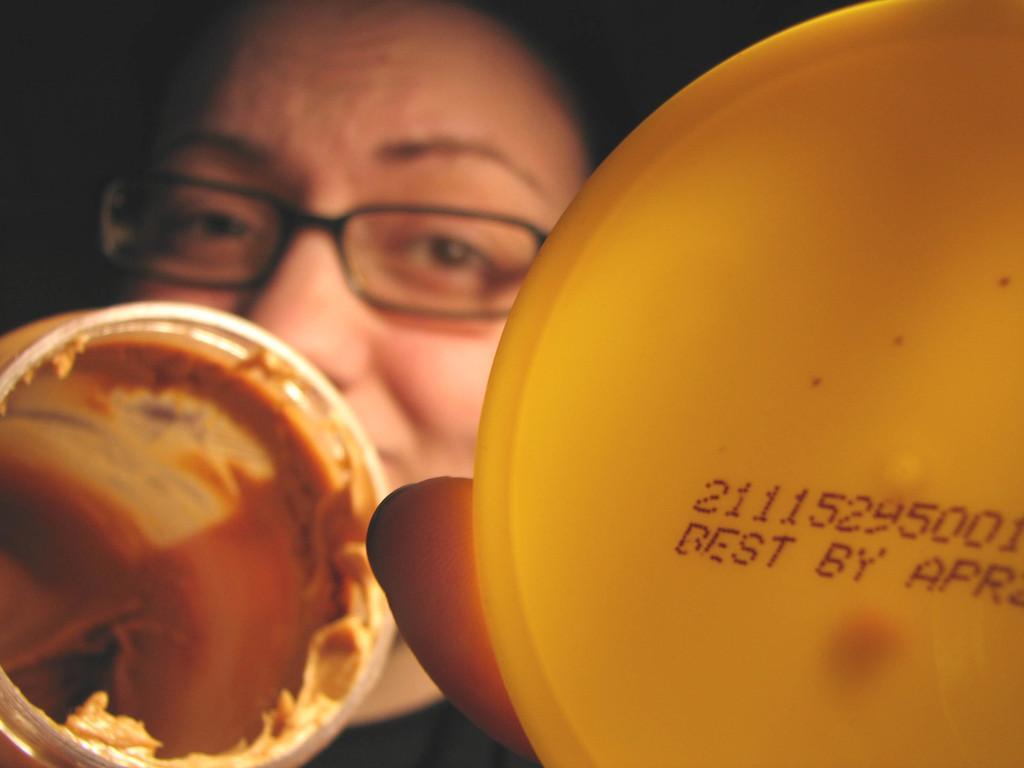Describe this image in one or two sentences. In this image there is a person holding jar and cap in his hands, in the background it is dark. 